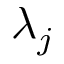Convert formula to latex. <formula><loc_0><loc_0><loc_500><loc_500>\lambda _ { j }</formula> 